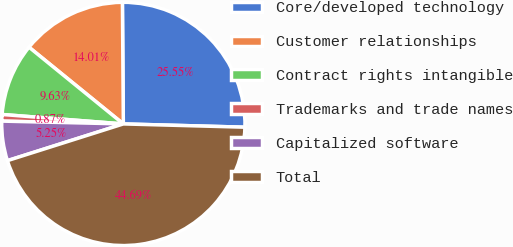<chart> <loc_0><loc_0><loc_500><loc_500><pie_chart><fcel>Core/developed technology<fcel>Customer relationships<fcel>Contract rights intangible<fcel>Trademarks and trade names<fcel>Capitalized software<fcel>Total<nl><fcel>25.55%<fcel>14.01%<fcel>9.63%<fcel>0.87%<fcel>5.25%<fcel>44.69%<nl></chart> 